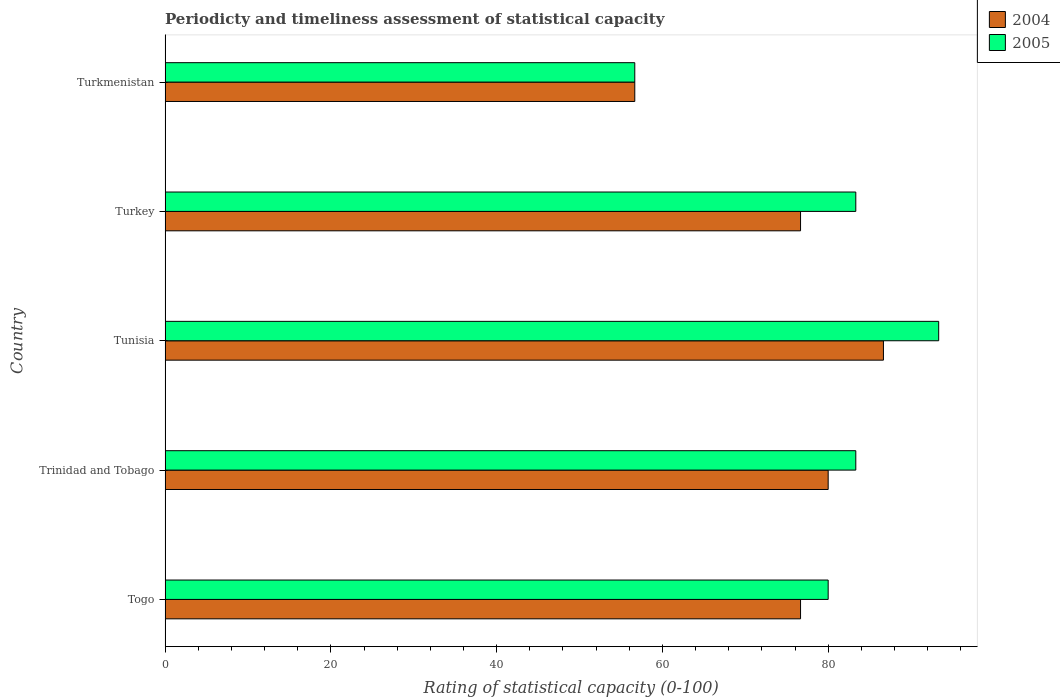How many different coloured bars are there?
Offer a terse response. 2. How many groups of bars are there?
Ensure brevity in your answer.  5. Are the number of bars per tick equal to the number of legend labels?
Keep it short and to the point. Yes. What is the label of the 5th group of bars from the top?
Provide a succinct answer. Togo. In how many cases, is the number of bars for a given country not equal to the number of legend labels?
Make the answer very short. 0. What is the rating of statistical capacity in 2004 in Turkmenistan?
Your answer should be compact. 56.67. Across all countries, what is the maximum rating of statistical capacity in 2005?
Provide a short and direct response. 93.33. Across all countries, what is the minimum rating of statistical capacity in 2004?
Your response must be concise. 56.67. In which country was the rating of statistical capacity in 2005 maximum?
Offer a terse response. Tunisia. In which country was the rating of statistical capacity in 2004 minimum?
Your answer should be very brief. Turkmenistan. What is the total rating of statistical capacity in 2005 in the graph?
Offer a very short reply. 396.67. What is the difference between the rating of statistical capacity in 2005 in Turkey and that in Turkmenistan?
Offer a terse response. 26.67. What is the difference between the rating of statistical capacity in 2004 in Tunisia and the rating of statistical capacity in 2005 in Togo?
Offer a terse response. 6.67. What is the average rating of statistical capacity in 2004 per country?
Offer a very short reply. 75.33. What is the difference between the rating of statistical capacity in 2005 and rating of statistical capacity in 2004 in Togo?
Your response must be concise. 3.33. In how many countries, is the rating of statistical capacity in 2004 greater than 12 ?
Make the answer very short. 5. What is the ratio of the rating of statistical capacity in 2004 in Trinidad and Tobago to that in Tunisia?
Provide a succinct answer. 0.92. Is the rating of statistical capacity in 2005 in Tunisia less than that in Turkey?
Provide a succinct answer. No. What is the difference between the highest and the lowest rating of statistical capacity in 2005?
Provide a succinct answer. 36.67. Is the sum of the rating of statistical capacity in 2004 in Trinidad and Tobago and Turkmenistan greater than the maximum rating of statistical capacity in 2005 across all countries?
Offer a very short reply. Yes. What does the 2nd bar from the top in Togo represents?
Your answer should be very brief. 2004. What does the 1st bar from the bottom in Tunisia represents?
Make the answer very short. 2004. How many bars are there?
Offer a terse response. 10. Are all the bars in the graph horizontal?
Your answer should be compact. Yes. What is the title of the graph?
Your response must be concise. Periodicty and timeliness assessment of statistical capacity. What is the label or title of the X-axis?
Your answer should be very brief. Rating of statistical capacity (0-100). What is the label or title of the Y-axis?
Your answer should be compact. Country. What is the Rating of statistical capacity (0-100) in 2004 in Togo?
Provide a short and direct response. 76.67. What is the Rating of statistical capacity (0-100) in 2005 in Togo?
Offer a very short reply. 80. What is the Rating of statistical capacity (0-100) in 2005 in Trinidad and Tobago?
Your answer should be very brief. 83.33. What is the Rating of statistical capacity (0-100) of 2004 in Tunisia?
Provide a short and direct response. 86.67. What is the Rating of statistical capacity (0-100) of 2005 in Tunisia?
Give a very brief answer. 93.33. What is the Rating of statistical capacity (0-100) in 2004 in Turkey?
Provide a succinct answer. 76.67. What is the Rating of statistical capacity (0-100) in 2005 in Turkey?
Make the answer very short. 83.33. What is the Rating of statistical capacity (0-100) in 2004 in Turkmenistan?
Your response must be concise. 56.67. What is the Rating of statistical capacity (0-100) in 2005 in Turkmenistan?
Your answer should be very brief. 56.67. Across all countries, what is the maximum Rating of statistical capacity (0-100) in 2004?
Your answer should be very brief. 86.67. Across all countries, what is the maximum Rating of statistical capacity (0-100) of 2005?
Offer a very short reply. 93.33. Across all countries, what is the minimum Rating of statistical capacity (0-100) of 2004?
Offer a terse response. 56.67. Across all countries, what is the minimum Rating of statistical capacity (0-100) of 2005?
Your response must be concise. 56.67. What is the total Rating of statistical capacity (0-100) in 2004 in the graph?
Keep it short and to the point. 376.67. What is the total Rating of statistical capacity (0-100) of 2005 in the graph?
Your answer should be compact. 396.67. What is the difference between the Rating of statistical capacity (0-100) in 2004 in Togo and that in Trinidad and Tobago?
Give a very brief answer. -3.33. What is the difference between the Rating of statistical capacity (0-100) of 2005 in Togo and that in Tunisia?
Your response must be concise. -13.33. What is the difference between the Rating of statistical capacity (0-100) in 2004 in Togo and that in Turkey?
Your answer should be very brief. 0. What is the difference between the Rating of statistical capacity (0-100) in 2004 in Togo and that in Turkmenistan?
Your response must be concise. 20. What is the difference between the Rating of statistical capacity (0-100) of 2005 in Togo and that in Turkmenistan?
Your answer should be compact. 23.33. What is the difference between the Rating of statistical capacity (0-100) in 2004 in Trinidad and Tobago and that in Tunisia?
Offer a very short reply. -6.67. What is the difference between the Rating of statistical capacity (0-100) of 2005 in Trinidad and Tobago and that in Turkey?
Make the answer very short. 0. What is the difference between the Rating of statistical capacity (0-100) of 2004 in Trinidad and Tobago and that in Turkmenistan?
Your answer should be very brief. 23.33. What is the difference between the Rating of statistical capacity (0-100) in 2005 in Trinidad and Tobago and that in Turkmenistan?
Offer a terse response. 26.67. What is the difference between the Rating of statistical capacity (0-100) of 2005 in Tunisia and that in Turkmenistan?
Make the answer very short. 36.67. What is the difference between the Rating of statistical capacity (0-100) of 2005 in Turkey and that in Turkmenistan?
Provide a succinct answer. 26.67. What is the difference between the Rating of statistical capacity (0-100) of 2004 in Togo and the Rating of statistical capacity (0-100) of 2005 in Trinidad and Tobago?
Your answer should be very brief. -6.67. What is the difference between the Rating of statistical capacity (0-100) of 2004 in Togo and the Rating of statistical capacity (0-100) of 2005 in Tunisia?
Ensure brevity in your answer.  -16.67. What is the difference between the Rating of statistical capacity (0-100) in 2004 in Togo and the Rating of statistical capacity (0-100) in 2005 in Turkey?
Provide a succinct answer. -6.67. What is the difference between the Rating of statistical capacity (0-100) in 2004 in Trinidad and Tobago and the Rating of statistical capacity (0-100) in 2005 in Tunisia?
Provide a short and direct response. -13.33. What is the difference between the Rating of statistical capacity (0-100) of 2004 in Trinidad and Tobago and the Rating of statistical capacity (0-100) of 2005 in Turkey?
Offer a terse response. -3.33. What is the difference between the Rating of statistical capacity (0-100) in 2004 in Trinidad and Tobago and the Rating of statistical capacity (0-100) in 2005 in Turkmenistan?
Make the answer very short. 23.33. What is the difference between the Rating of statistical capacity (0-100) in 2004 in Tunisia and the Rating of statistical capacity (0-100) in 2005 in Turkmenistan?
Your answer should be compact. 30. What is the average Rating of statistical capacity (0-100) in 2004 per country?
Your response must be concise. 75.33. What is the average Rating of statistical capacity (0-100) in 2005 per country?
Offer a very short reply. 79.33. What is the difference between the Rating of statistical capacity (0-100) of 2004 and Rating of statistical capacity (0-100) of 2005 in Togo?
Keep it short and to the point. -3.33. What is the difference between the Rating of statistical capacity (0-100) in 2004 and Rating of statistical capacity (0-100) in 2005 in Trinidad and Tobago?
Your answer should be compact. -3.33. What is the difference between the Rating of statistical capacity (0-100) in 2004 and Rating of statistical capacity (0-100) in 2005 in Tunisia?
Give a very brief answer. -6.67. What is the difference between the Rating of statistical capacity (0-100) in 2004 and Rating of statistical capacity (0-100) in 2005 in Turkey?
Your response must be concise. -6.67. What is the ratio of the Rating of statistical capacity (0-100) of 2004 in Togo to that in Tunisia?
Your response must be concise. 0.88. What is the ratio of the Rating of statistical capacity (0-100) in 2004 in Togo to that in Turkey?
Your answer should be compact. 1. What is the ratio of the Rating of statistical capacity (0-100) of 2005 in Togo to that in Turkey?
Your answer should be very brief. 0.96. What is the ratio of the Rating of statistical capacity (0-100) in 2004 in Togo to that in Turkmenistan?
Ensure brevity in your answer.  1.35. What is the ratio of the Rating of statistical capacity (0-100) of 2005 in Togo to that in Turkmenistan?
Offer a terse response. 1.41. What is the ratio of the Rating of statistical capacity (0-100) of 2004 in Trinidad and Tobago to that in Tunisia?
Provide a short and direct response. 0.92. What is the ratio of the Rating of statistical capacity (0-100) in 2005 in Trinidad and Tobago to that in Tunisia?
Offer a very short reply. 0.89. What is the ratio of the Rating of statistical capacity (0-100) in 2004 in Trinidad and Tobago to that in Turkey?
Your answer should be compact. 1.04. What is the ratio of the Rating of statistical capacity (0-100) of 2004 in Trinidad and Tobago to that in Turkmenistan?
Provide a succinct answer. 1.41. What is the ratio of the Rating of statistical capacity (0-100) of 2005 in Trinidad and Tobago to that in Turkmenistan?
Ensure brevity in your answer.  1.47. What is the ratio of the Rating of statistical capacity (0-100) of 2004 in Tunisia to that in Turkey?
Ensure brevity in your answer.  1.13. What is the ratio of the Rating of statistical capacity (0-100) in 2005 in Tunisia to that in Turkey?
Ensure brevity in your answer.  1.12. What is the ratio of the Rating of statistical capacity (0-100) in 2004 in Tunisia to that in Turkmenistan?
Provide a succinct answer. 1.53. What is the ratio of the Rating of statistical capacity (0-100) of 2005 in Tunisia to that in Turkmenistan?
Your response must be concise. 1.65. What is the ratio of the Rating of statistical capacity (0-100) of 2004 in Turkey to that in Turkmenistan?
Your response must be concise. 1.35. What is the ratio of the Rating of statistical capacity (0-100) of 2005 in Turkey to that in Turkmenistan?
Your answer should be compact. 1.47. What is the difference between the highest and the lowest Rating of statistical capacity (0-100) in 2004?
Provide a short and direct response. 30. What is the difference between the highest and the lowest Rating of statistical capacity (0-100) in 2005?
Provide a succinct answer. 36.67. 